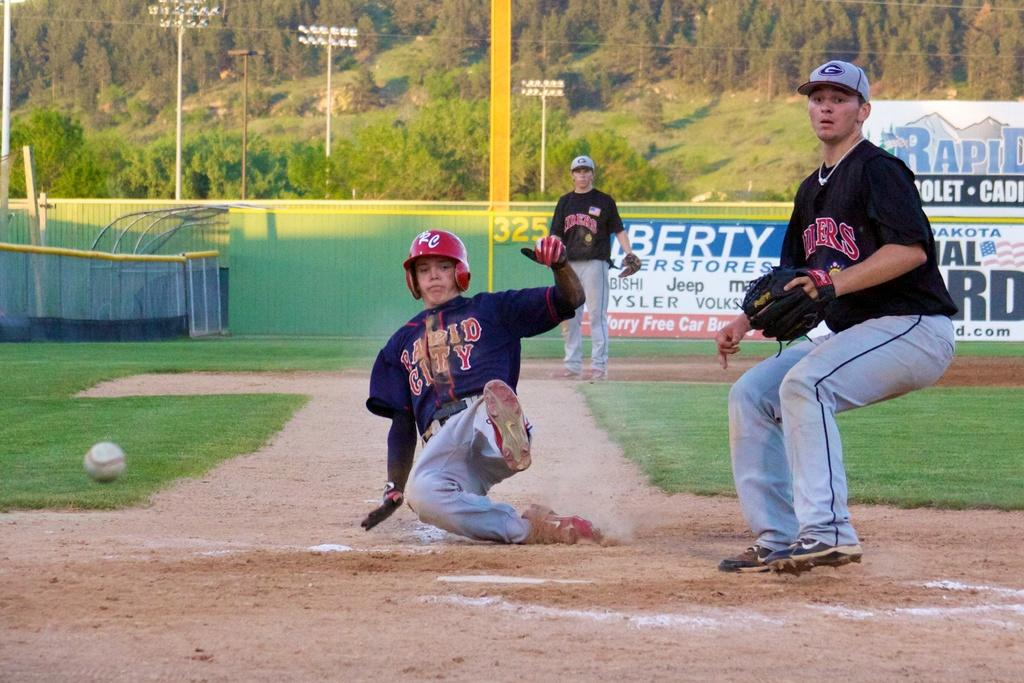<image>
Present a compact description of the photo's key features. Baseball player wearing a jersey that says Rapid City sliding to base. 